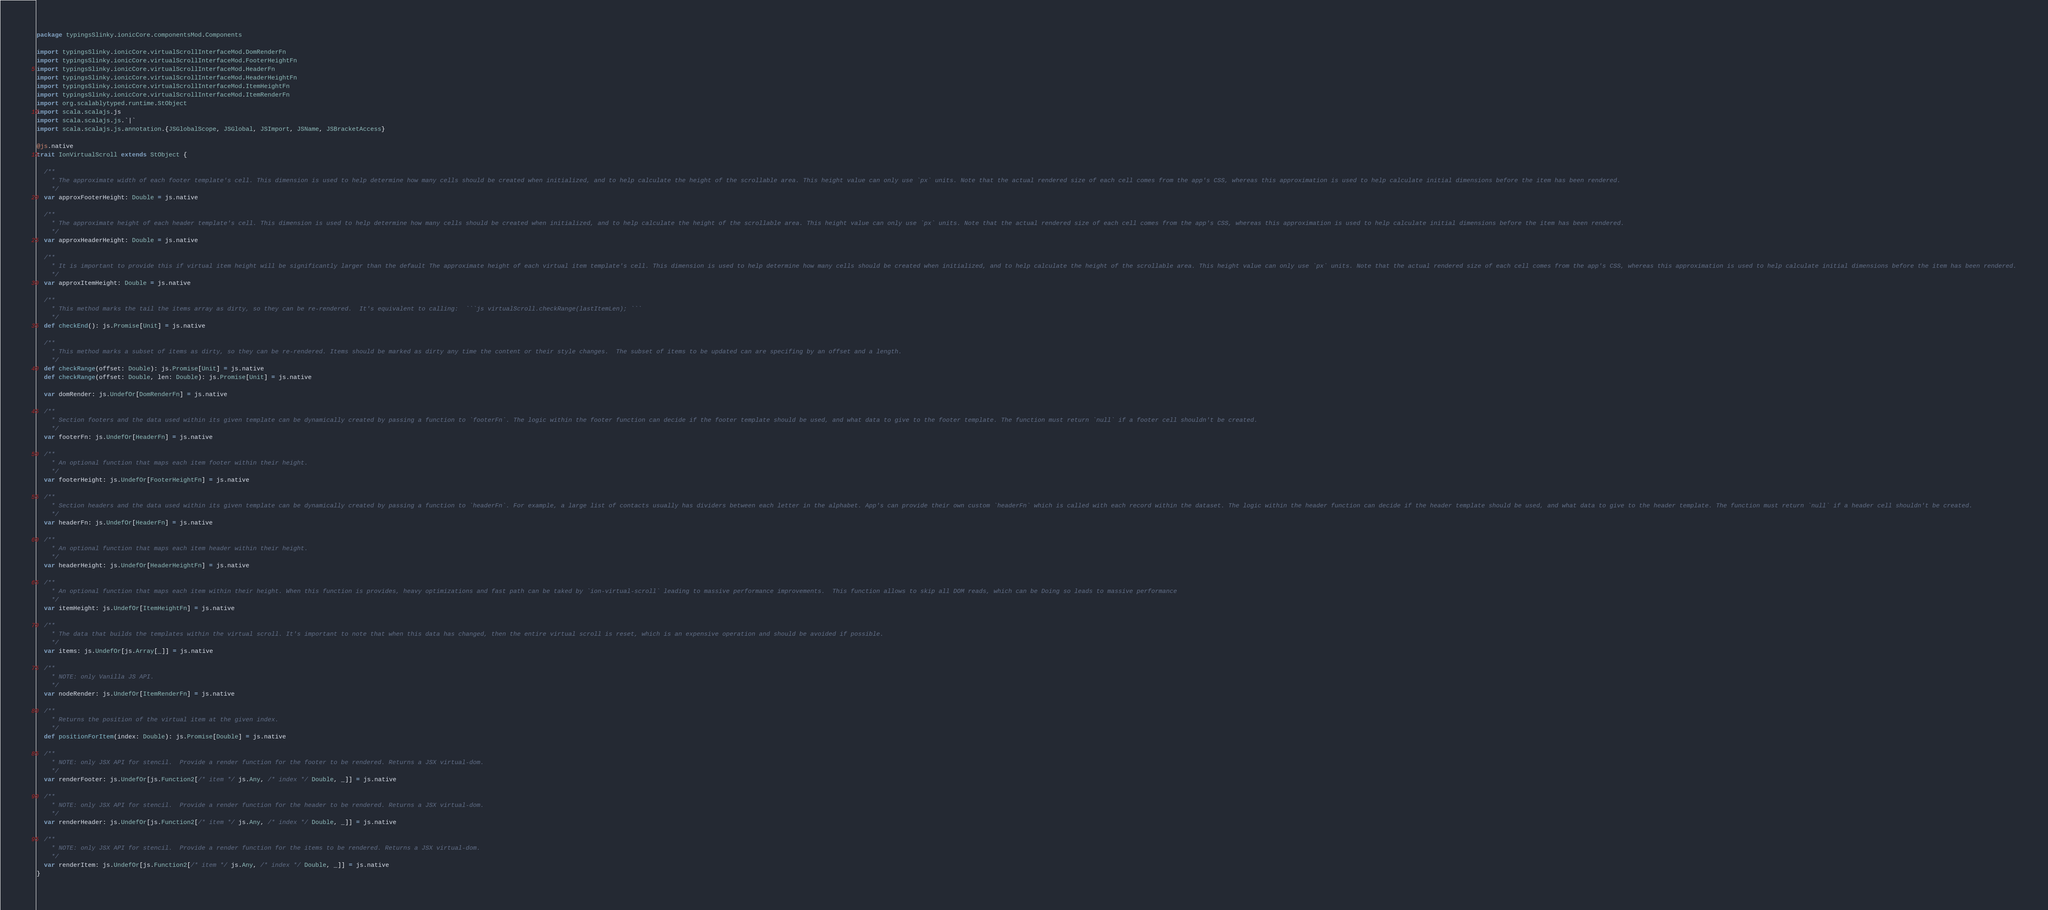<code> <loc_0><loc_0><loc_500><loc_500><_Scala_>package typingsSlinky.ionicCore.componentsMod.Components

import typingsSlinky.ionicCore.virtualScrollInterfaceMod.DomRenderFn
import typingsSlinky.ionicCore.virtualScrollInterfaceMod.FooterHeightFn
import typingsSlinky.ionicCore.virtualScrollInterfaceMod.HeaderFn
import typingsSlinky.ionicCore.virtualScrollInterfaceMod.HeaderHeightFn
import typingsSlinky.ionicCore.virtualScrollInterfaceMod.ItemHeightFn
import typingsSlinky.ionicCore.virtualScrollInterfaceMod.ItemRenderFn
import org.scalablytyped.runtime.StObject
import scala.scalajs.js
import scala.scalajs.js.`|`
import scala.scalajs.js.annotation.{JSGlobalScope, JSGlobal, JSImport, JSName, JSBracketAccess}

@js.native
trait IonVirtualScroll extends StObject {
  
  /**
    * The approximate width of each footer template's cell. This dimension is used to help determine how many cells should be created when initialized, and to help calculate the height of the scrollable area. This height value can only use `px` units. Note that the actual rendered size of each cell comes from the app's CSS, whereas this approximation is used to help calculate initial dimensions before the item has been rendered.
    */
  var approxFooterHeight: Double = js.native
  
  /**
    * The approximate height of each header template's cell. This dimension is used to help determine how many cells should be created when initialized, and to help calculate the height of the scrollable area. This height value can only use `px` units. Note that the actual rendered size of each cell comes from the app's CSS, whereas this approximation is used to help calculate initial dimensions before the item has been rendered.
    */
  var approxHeaderHeight: Double = js.native
  
  /**
    * It is important to provide this if virtual item height will be significantly larger than the default The approximate height of each virtual item template's cell. This dimension is used to help determine how many cells should be created when initialized, and to help calculate the height of the scrollable area. This height value can only use `px` units. Note that the actual rendered size of each cell comes from the app's CSS, whereas this approximation is used to help calculate initial dimensions before the item has been rendered.
    */
  var approxItemHeight: Double = js.native
  
  /**
    * This method marks the tail the items array as dirty, so they can be re-rendered.  It's equivalent to calling:  ```js virtualScroll.checkRange(lastItemLen); ```
    */
  def checkEnd(): js.Promise[Unit] = js.native
  
  /**
    * This method marks a subset of items as dirty, so they can be re-rendered. Items should be marked as dirty any time the content or their style changes.  The subset of items to be updated can are specifing by an offset and a length.
    */
  def checkRange(offset: Double): js.Promise[Unit] = js.native
  def checkRange(offset: Double, len: Double): js.Promise[Unit] = js.native
  
  var domRender: js.UndefOr[DomRenderFn] = js.native
  
  /**
    * Section footers and the data used within its given template can be dynamically created by passing a function to `footerFn`. The logic within the footer function can decide if the footer template should be used, and what data to give to the footer template. The function must return `null` if a footer cell shouldn't be created.
    */
  var footerFn: js.UndefOr[HeaderFn] = js.native
  
  /**
    * An optional function that maps each item footer within their height.
    */
  var footerHeight: js.UndefOr[FooterHeightFn] = js.native
  
  /**
    * Section headers and the data used within its given template can be dynamically created by passing a function to `headerFn`. For example, a large list of contacts usually has dividers between each letter in the alphabet. App's can provide their own custom `headerFn` which is called with each record within the dataset. The logic within the header function can decide if the header template should be used, and what data to give to the header template. The function must return `null` if a header cell shouldn't be created.
    */
  var headerFn: js.UndefOr[HeaderFn] = js.native
  
  /**
    * An optional function that maps each item header within their height.
    */
  var headerHeight: js.UndefOr[HeaderHeightFn] = js.native
  
  /**
    * An optional function that maps each item within their height. When this function is provides, heavy optimizations and fast path can be taked by `ion-virtual-scroll` leading to massive performance improvements.  This function allows to skip all DOM reads, which can be Doing so leads to massive performance
    */
  var itemHeight: js.UndefOr[ItemHeightFn] = js.native
  
  /**
    * The data that builds the templates within the virtual scroll. It's important to note that when this data has changed, then the entire virtual scroll is reset, which is an expensive operation and should be avoided if possible.
    */
  var items: js.UndefOr[js.Array[_]] = js.native
  
  /**
    * NOTE: only Vanilla JS API.
    */
  var nodeRender: js.UndefOr[ItemRenderFn] = js.native
  
  /**
    * Returns the position of the virtual item at the given index.
    */
  def positionForItem(index: Double): js.Promise[Double] = js.native
  
  /**
    * NOTE: only JSX API for stencil.  Provide a render function for the footer to be rendered. Returns a JSX virtual-dom.
    */
  var renderFooter: js.UndefOr[js.Function2[/* item */ js.Any, /* index */ Double, _]] = js.native
  
  /**
    * NOTE: only JSX API for stencil.  Provide a render function for the header to be rendered. Returns a JSX virtual-dom.
    */
  var renderHeader: js.UndefOr[js.Function2[/* item */ js.Any, /* index */ Double, _]] = js.native
  
  /**
    * NOTE: only JSX API for stencil.  Provide a render function for the items to be rendered. Returns a JSX virtual-dom.
    */
  var renderItem: js.UndefOr[js.Function2[/* item */ js.Any, /* index */ Double, _]] = js.native
}
</code> 